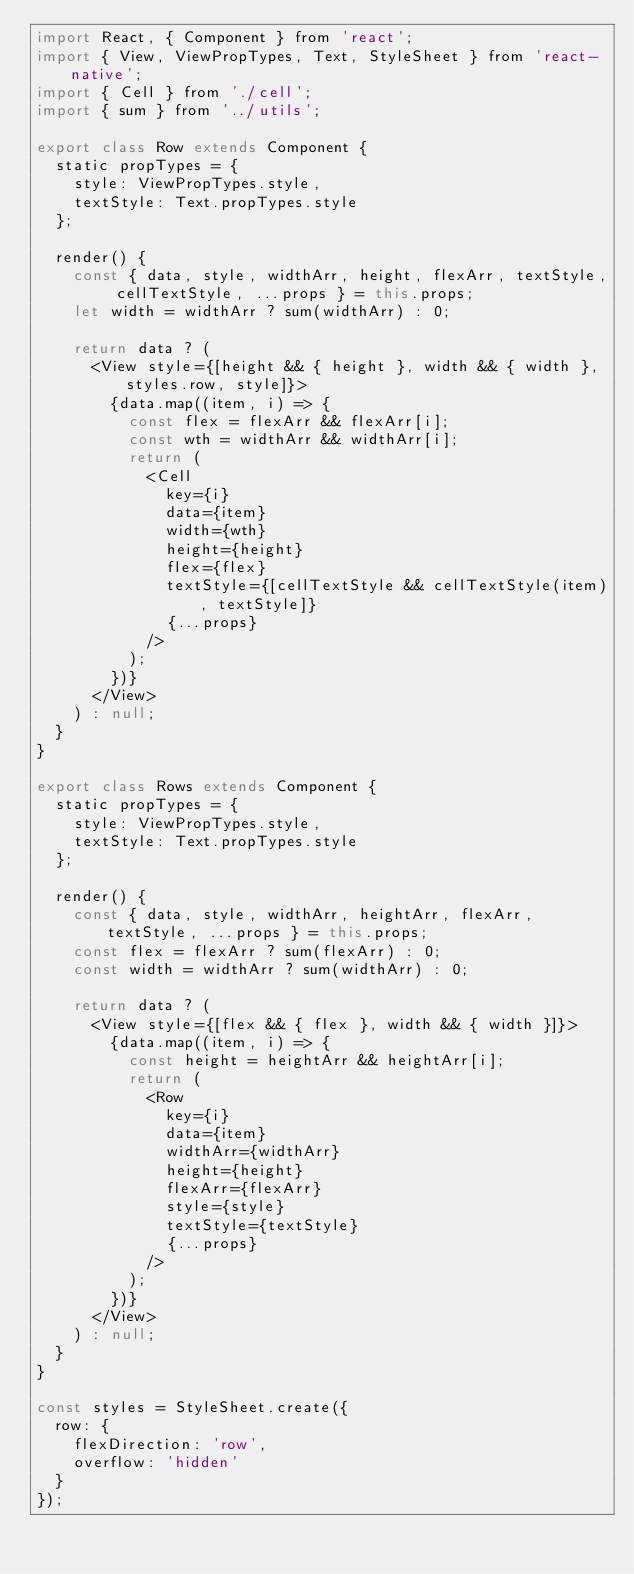Convert code to text. <code><loc_0><loc_0><loc_500><loc_500><_JavaScript_>import React, { Component } from 'react';
import { View, ViewPropTypes, Text, StyleSheet } from 'react-native';
import { Cell } from './cell';
import { sum } from '../utils';

export class Row extends Component {
  static propTypes = {
    style: ViewPropTypes.style,
    textStyle: Text.propTypes.style
  };

  render() {
    const { data, style, widthArr, height, flexArr, textStyle, cellTextStyle, ...props } = this.props;
    let width = widthArr ? sum(widthArr) : 0;

    return data ? (
      <View style={[height && { height }, width && { width }, styles.row, style]}>
        {data.map((item, i) => {
          const flex = flexArr && flexArr[i];
          const wth = widthArr && widthArr[i];
          return (
            <Cell
              key={i}
              data={item}
              width={wth}
              height={height}
              flex={flex}
              textStyle={[cellTextStyle && cellTextStyle(item), textStyle]}
              {...props}
            />
          );
        })}
      </View>
    ) : null;
  }
}

export class Rows extends Component {
  static propTypes = {
    style: ViewPropTypes.style,
    textStyle: Text.propTypes.style
  };

  render() {
    const { data, style, widthArr, heightArr, flexArr, textStyle, ...props } = this.props;
    const flex = flexArr ? sum(flexArr) : 0;
    const width = widthArr ? sum(widthArr) : 0;

    return data ? (
      <View style={[flex && { flex }, width && { width }]}>
        {data.map((item, i) => {
          const height = heightArr && heightArr[i];
          return (
            <Row
              key={i}
              data={item}
              widthArr={widthArr}
              height={height}
              flexArr={flexArr}
              style={style}
              textStyle={textStyle}
              {...props}
            />
          );
        })}
      </View>
    ) : null;
  }
}

const styles = StyleSheet.create({
  row: {
    flexDirection: 'row',
    overflow: 'hidden'
  }
});
</code> 